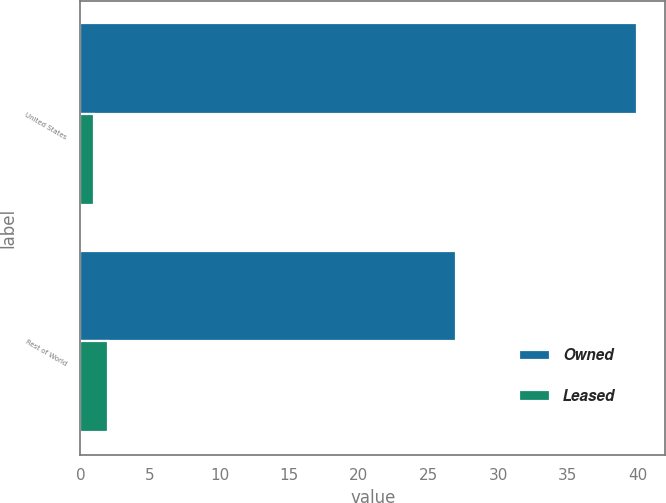Convert chart. <chart><loc_0><loc_0><loc_500><loc_500><stacked_bar_chart><ecel><fcel>United States<fcel>Rest of World<nl><fcel>Owned<fcel>40<fcel>27<nl><fcel>Leased<fcel>1<fcel>2<nl></chart> 